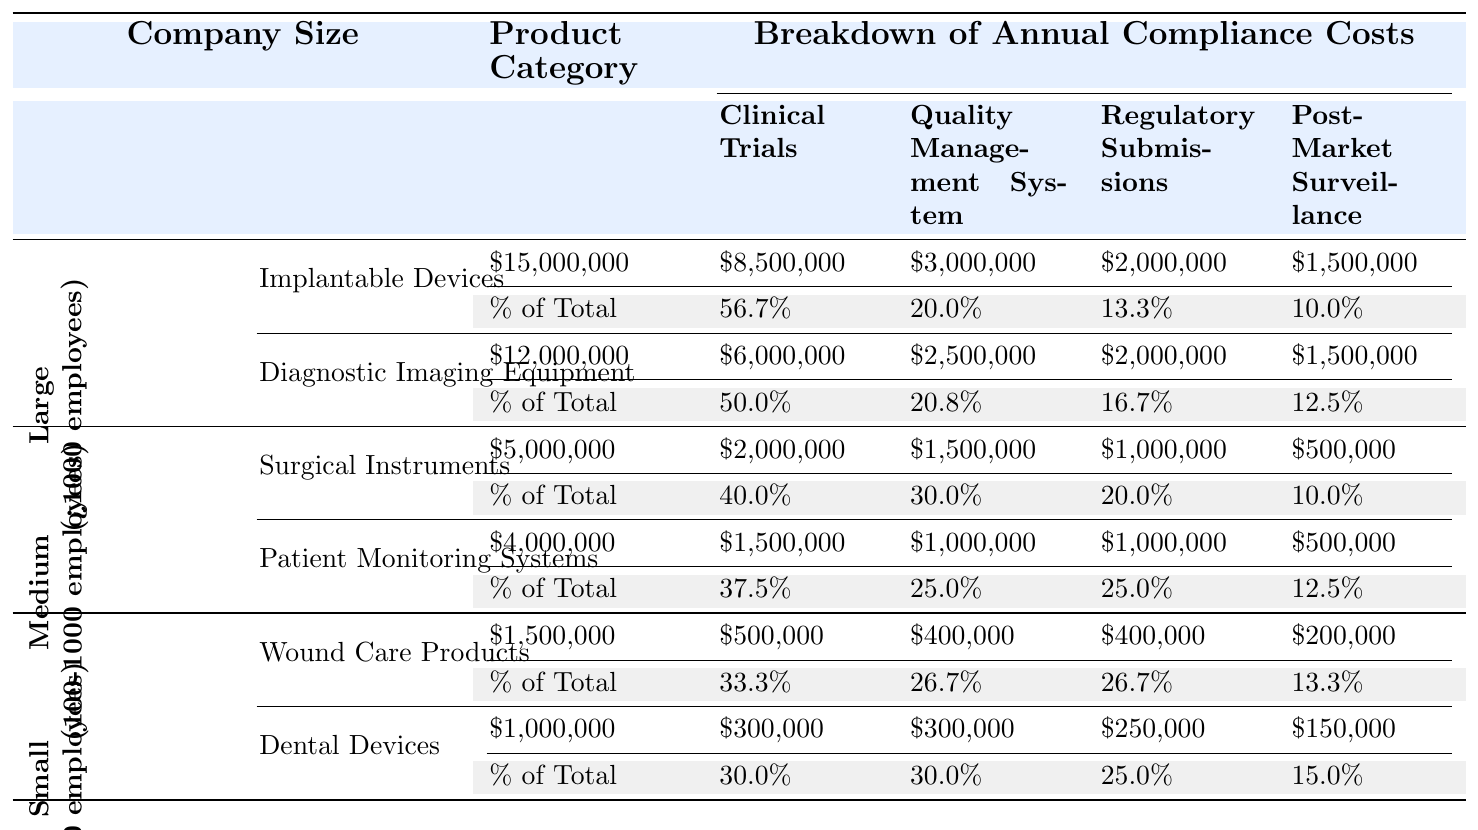What are the annual compliance costs for Implantable Devices from Large companies? The table shows that the annual compliance costs for Implantable Devices from Large companies is $15,000,000.
Answer: $15,000,000 Which company size has the highest annual compliance costs for Patient Monitoring Systems? The compliance costs for Patient Monitoring Systems from Medium companies is $4,000,000, which is the only value listed for that product. Therefore, Medium companies have the highest costs for this category.
Answer: Medium companies What percentage of the total compliance costs for Surgical Instruments comes from Clinical Trials? For Surgical Instruments from Medium companies, the annual compliance cost is $5,000,000, and the Clinical Trials cost is $2,000,000. To find the percentage, divide $2,000,000 by $5,000,000, resulting in 40%.
Answer: 40% Which company size spends more on Regulatory Submissions: Small or Medium companies? For Small companies, Dental Devices have $250,000 and Wound Care Products have $400,000 for Regulatory Submissions. This sums to $650,000. For Medium companies, Surgical Instruments have $1,000,000 and Patient Monitoring Systems also have $1,000,000, summing to $2,000,000. Since $2,000,000 is greater than $650,000, Medium companies spend more.
Answer: Medium companies What is the total annual compliance cost for all product categories for Large companies? The total annual compliance costs for Large companies are $15,000,000 (Implantable Devices) + $12,000,000 (Diagnostic Imaging Equipment) = $27,000,000.
Answer: $27,000,000 Are the annual compliance costs for Dental Devices lower than those for Wound Care Products from Small companies? The annual compliance costs for Dental Devices are $1,000,000 and for Wound Care Products are $1,500,000. Since $1,000,000 is less than $1,500,000, the statement is true.
Answer: Yes How does the percentage breakdown of Post-Market Surveillance costs compare between Wound Care Products and Dental Devices? For Wound Care Products, Post-Market Surveillance is $200,000 out of $1,500,000, making it about 13.3%. For Dental Devices, it's $150,000 out of $1,000,000, resulting in 15%. Thus, Dental Devices have a higher percentage for Post-Market Surveillance costs.
Answer: Dental Devices What is the average annual compliance cost for Medium-sized companies? The annual compliance costs for Medium companies are $5,000,000 (Surgical Instruments) and $4,000,000 (Patient Monitoring Systems). Adding these gives $9,000,000, and dividing by 2 gives an average of $4,500,000.
Answer: $4,500,000 Which category incurs the highest total annual compliance cost among all companies? For the total annual compliance cost comparison, $15,000,000 (Implantable Devices) and $12,000,000 (Diagnostic Imaging Equipment) from Large companies is the highest, so Implantable Devices incur the highest cost.
Answer: Implantable Devices What is the difference in compliance costs for clinical trials between the Implantable Devices and the Wound Care Products? The cost for Clinical Trials for Implantable Devices is $8,500,000, while for Wound Care Products, it is $500,000. The difference is $8,500,000 - $500,000 = $8,000,000.
Answer: $8,000,000 Given the data, can we say that compliance costs for the Implantable Devices is the lowest among all products? The compliance costs for Implantable Devices are $15,000,000, which is higher than the costs for Wound Care Products ($1,500,000) and Dental Devices ($1,000,000), hence this statement is false.
Answer: No 